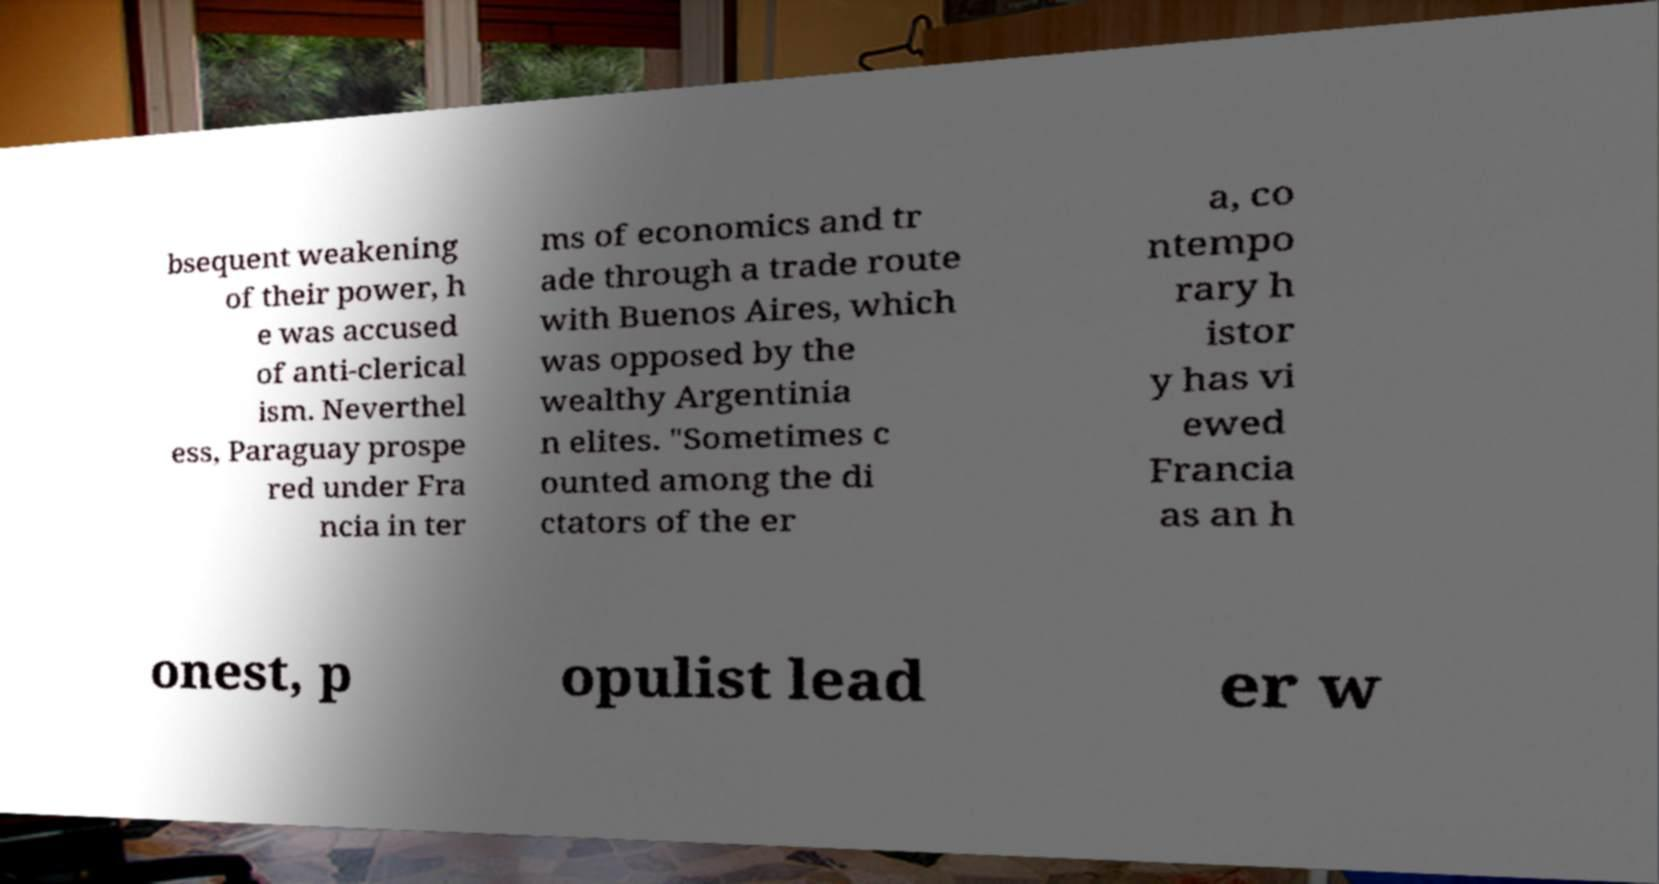I need the written content from this picture converted into text. Can you do that? bsequent weakening of their power, h e was accused of anti-clerical ism. Neverthel ess, Paraguay prospe red under Fra ncia in ter ms of economics and tr ade through a trade route with Buenos Aires, which was opposed by the wealthy Argentinia n elites. "Sometimes c ounted among the di ctators of the er a, co ntempo rary h istor y has vi ewed Francia as an h onest, p opulist lead er w 